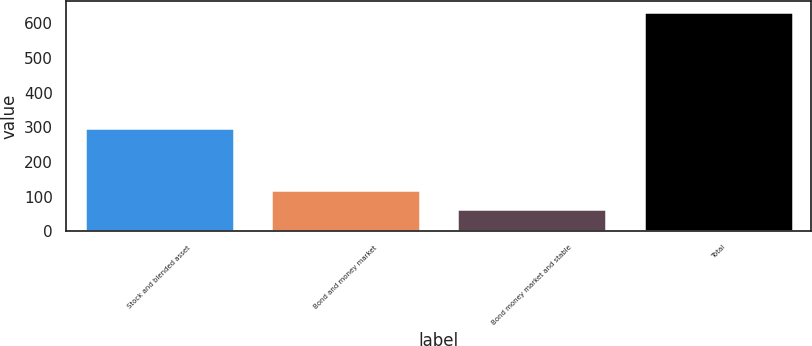Convert chart to OTSL. <chart><loc_0><loc_0><loc_500><loc_500><bar_chart><fcel>Stock and blended asset<fcel>Bond and money market<fcel>Bond money market and stable<fcel>Total<nl><fcel>299.1<fcel>120.35<fcel>63.3<fcel>633.8<nl></chart> 